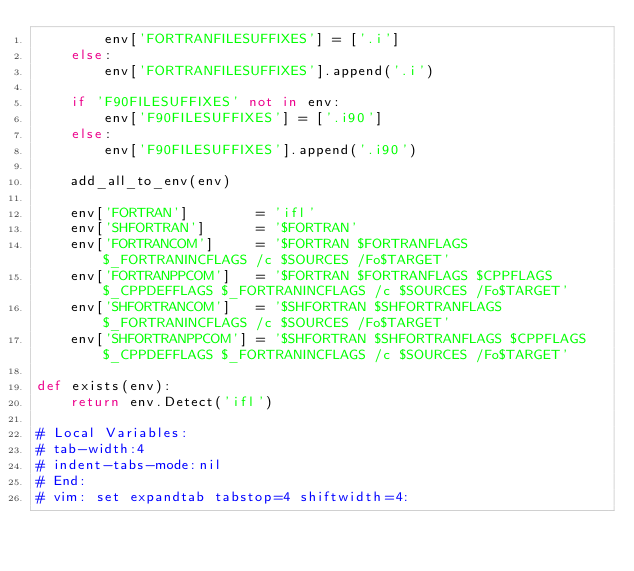<code> <loc_0><loc_0><loc_500><loc_500><_Python_>        env['FORTRANFILESUFFIXES'] = ['.i']
    else:
        env['FORTRANFILESUFFIXES'].append('.i')

    if 'F90FILESUFFIXES' not in env:
        env['F90FILESUFFIXES'] = ['.i90']
    else:
        env['F90FILESUFFIXES'].append('.i90')

    add_all_to_env(env)

    env['FORTRAN']        = 'ifl'
    env['SHFORTRAN']      = '$FORTRAN'
    env['FORTRANCOM']     = '$FORTRAN $FORTRANFLAGS $_FORTRANINCFLAGS /c $SOURCES /Fo$TARGET'
    env['FORTRANPPCOM']   = '$FORTRAN $FORTRANFLAGS $CPPFLAGS $_CPPDEFFLAGS $_FORTRANINCFLAGS /c $SOURCES /Fo$TARGET'
    env['SHFORTRANCOM']   = '$SHFORTRAN $SHFORTRANFLAGS $_FORTRANINCFLAGS /c $SOURCES /Fo$TARGET'
    env['SHFORTRANPPCOM'] = '$SHFORTRAN $SHFORTRANFLAGS $CPPFLAGS $_CPPDEFFLAGS $_FORTRANINCFLAGS /c $SOURCES /Fo$TARGET'

def exists(env):
    return env.Detect('ifl')

# Local Variables:
# tab-width:4
# indent-tabs-mode:nil
# End:
# vim: set expandtab tabstop=4 shiftwidth=4:
</code> 